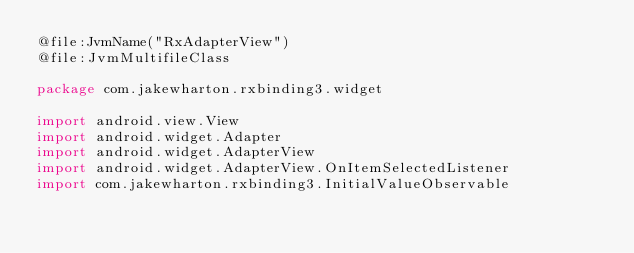Convert code to text. <code><loc_0><loc_0><loc_500><loc_500><_Kotlin_>@file:JvmName("RxAdapterView")
@file:JvmMultifileClass

package com.jakewharton.rxbinding3.widget

import android.view.View
import android.widget.Adapter
import android.widget.AdapterView
import android.widget.AdapterView.OnItemSelectedListener
import com.jakewharton.rxbinding3.InitialValueObservable</code> 